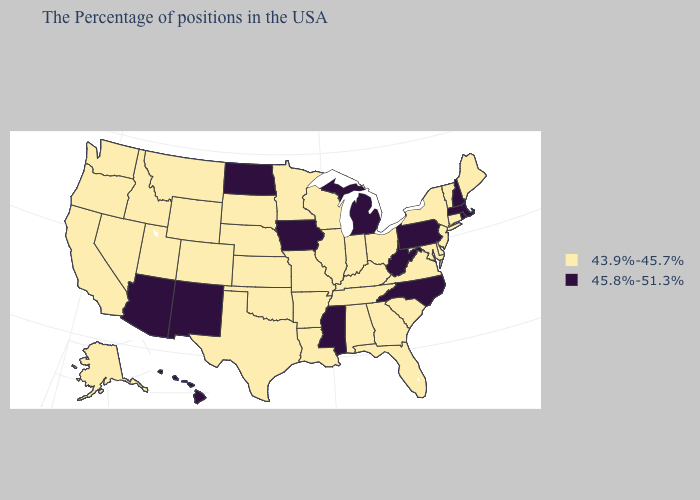What is the highest value in states that border Illinois?
Be succinct. 45.8%-51.3%. Does Georgia have the same value as New York?
Short answer required. Yes. Name the states that have a value in the range 43.9%-45.7%?
Answer briefly. Maine, Vermont, Connecticut, New York, New Jersey, Delaware, Maryland, Virginia, South Carolina, Ohio, Florida, Georgia, Kentucky, Indiana, Alabama, Tennessee, Wisconsin, Illinois, Louisiana, Missouri, Arkansas, Minnesota, Kansas, Nebraska, Oklahoma, Texas, South Dakota, Wyoming, Colorado, Utah, Montana, Idaho, Nevada, California, Washington, Oregon, Alaska. Name the states that have a value in the range 45.8%-51.3%?
Write a very short answer. Massachusetts, Rhode Island, New Hampshire, Pennsylvania, North Carolina, West Virginia, Michigan, Mississippi, Iowa, North Dakota, New Mexico, Arizona, Hawaii. Does Maine have the lowest value in the USA?
Be succinct. Yes. Does Missouri have the lowest value in the MidWest?
Give a very brief answer. Yes. What is the value of Hawaii?
Short answer required. 45.8%-51.3%. What is the highest value in the USA?
Quick response, please. 45.8%-51.3%. What is the value of Kentucky?
Concise answer only. 43.9%-45.7%. What is the value of Colorado?
Give a very brief answer. 43.9%-45.7%. Is the legend a continuous bar?
Answer briefly. No. What is the lowest value in states that border Delaware?
Be succinct. 43.9%-45.7%. What is the lowest value in states that border Arizona?
Quick response, please. 43.9%-45.7%. What is the value of North Dakota?
Concise answer only. 45.8%-51.3%. 